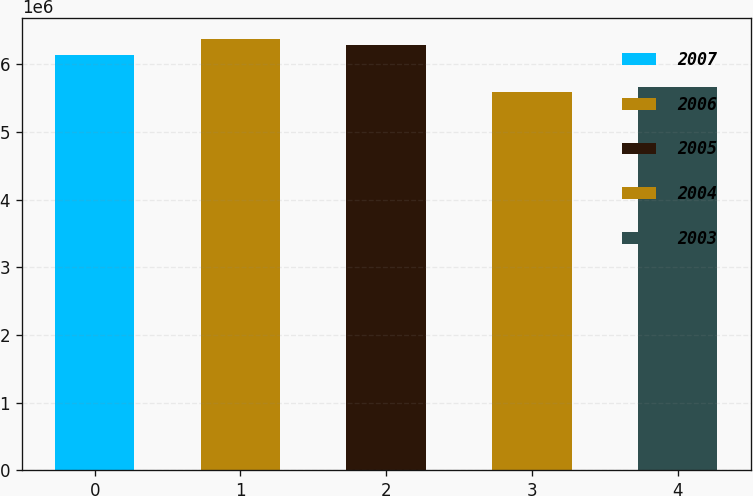Convert chart. <chart><loc_0><loc_0><loc_500><loc_500><bar_chart><fcel>2007<fcel>2006<fcel>2005<fcel>2004<fcel>2003<nl><fcel>6.139e+06<fcel>6.37e+06<fcel>6.29e+06<fcel>5.589e+06<fcel>5.6671e+06<nl></chart> 